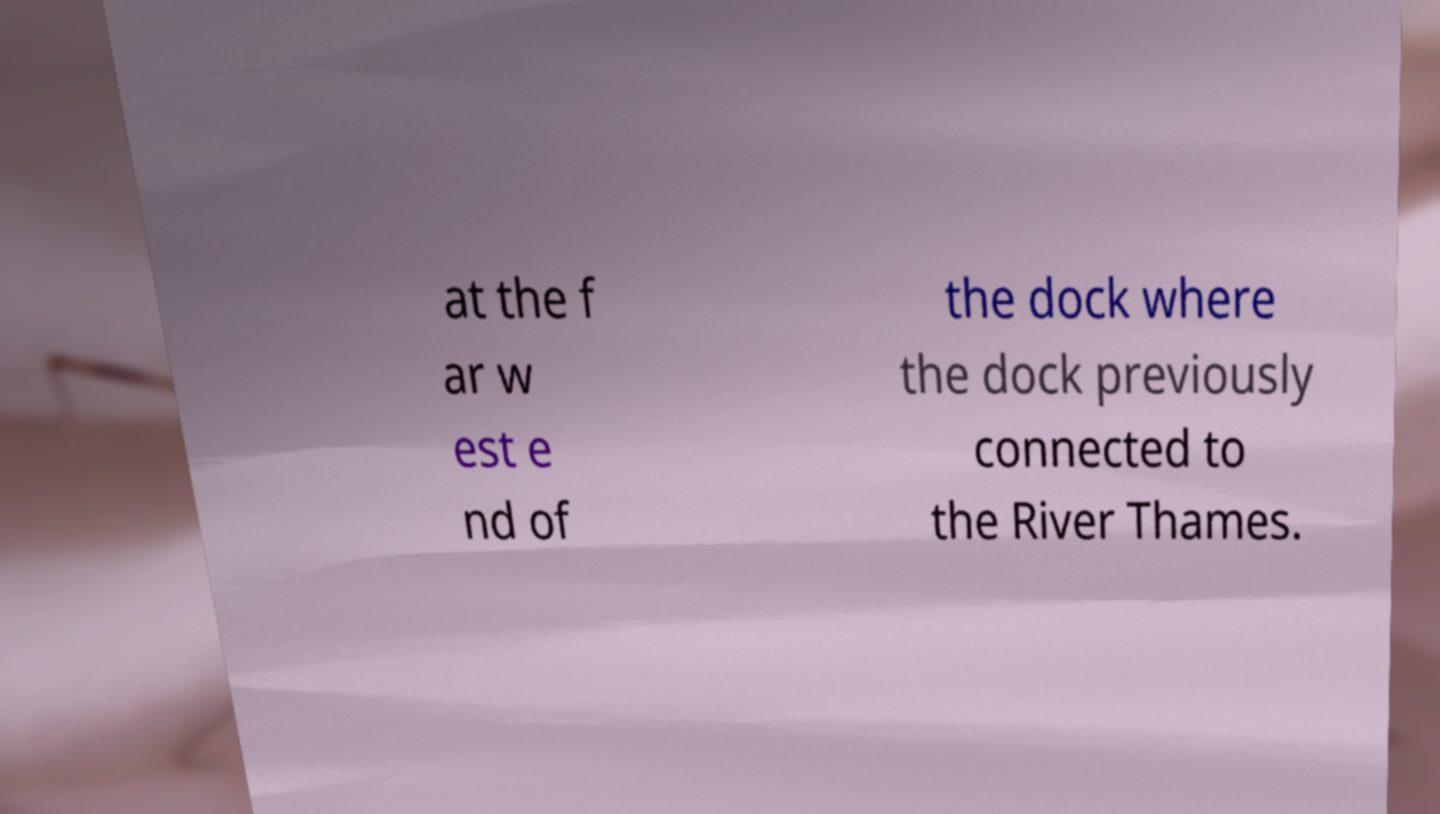Could you extract and type out the text from this image? at the f ar w est e nd of the dock where the dock previously connected to the River Thames. 